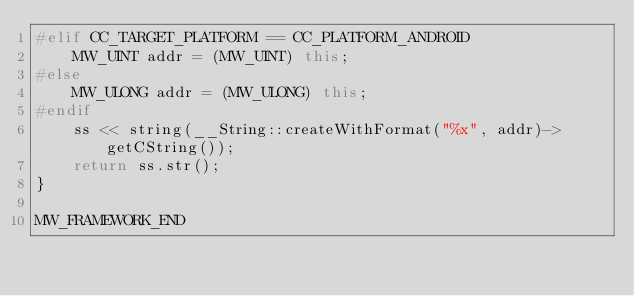Convert code to text. <code><loc_0><loc_0><loc_500><loc_500><_C++_>#elif CC_TARGET_PLATFORM == CC_PLATFORM_ANDROID
    MW_UINT addr = (MW_UINT) this;
#else
    MW_ULONG addr = (MW_ULONG) this;
#endif
    ss << string(__String::createWithFormat("%x", addr)->getCString());
    return ss.str();
}

MW_FRAMEWORK_END</code> 